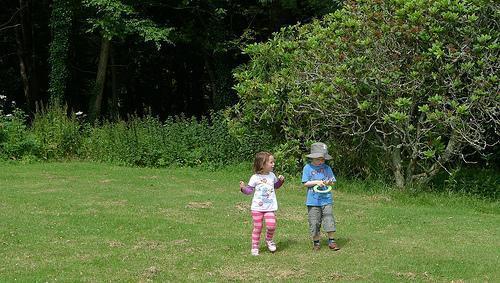How many kids are there?
Give a very brief answer. 2. 